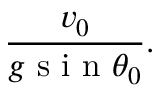Convert formula to latex. <formula><loc_0><loc_0><loc_500><loc_500>\frac { v _ { 0 } } { g \sin \theta _ { 0 } } .</formula> 